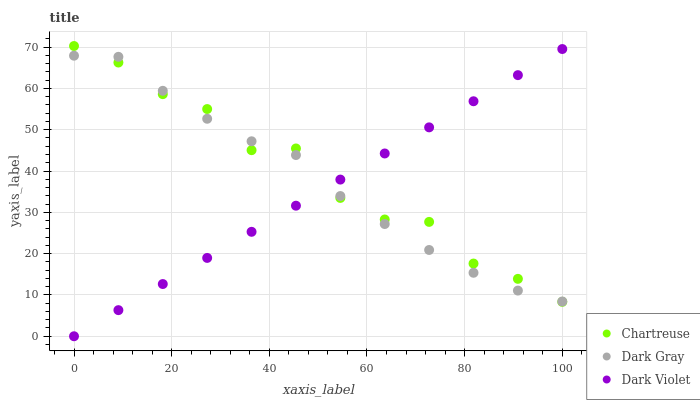Does Dark Violet have the minimum area under the curve?
Answer yes or no. Yes. Does Chartreuse have the maximum area under the curve?
Answer yes or no. Yes. Does Chartreuse have the minimum area under the curve?
Answer yes or no. No. Does Dark Violet have the maximum area under the curve?
Answer yes or no. No. Is Dark Violet the smoothest?
Answer yes or no. Yes. Is Chartreuse the roughest?
Answer yes or no. Yes. Is Chartreuse the smoothest?
Answer yes or no. No. Is Dark Violet the roughest?
Answer yes or no. No. Does Dark Violet have the lowest value?
Answer yes or no. Yes. Does Chartreuse have the lowest value?
Answer yes or no. No. Does Chartreuse have the highest value?
Answer yes or no. Yes. Does Dark Violet have the highest value?
Answer yes or no. No. Does Dark Gray intersect Chartreuse?
Answer yes or no. Yes. Is Dark Gray less than Chartreuse?
Answer yes or no. No. Is Dark Gray greater than Chartreuse?
Answer yes or no. No. 